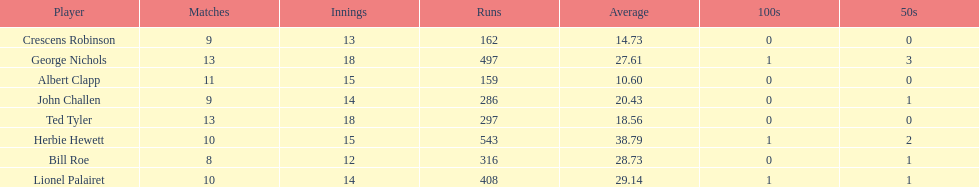How many innings did bill and ted have in total? 30. 